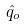<formula> <loc_0><loc_0><loc_500><loc_500>\hat { q } _ { o }</formula> 